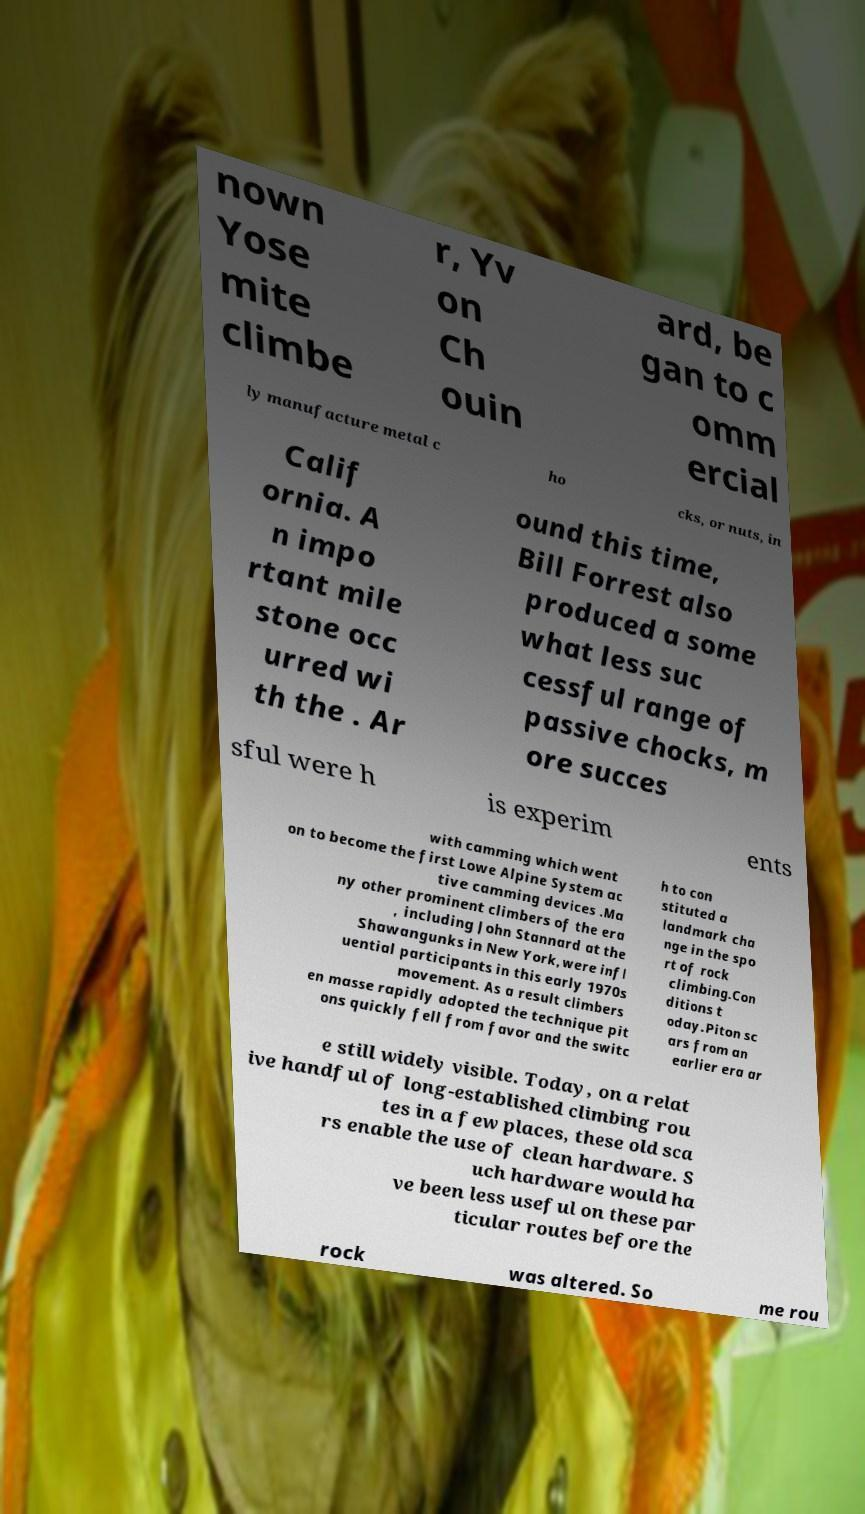There's text embedded in this image that I need extracted. Can you transcribe it verbatim? nown Yose mite climbe r, Yv on Ch ouin ard, be gan to c omm ercial ly manufacture metal c ho cks, or nuts, in Calif ornia. A n impo rtant mile stone occ urred wi th the . Ar ound this time, Bill Forrest also produced a some what less suc cessful range of passive chocks, m ore succes sful were h is experim ents with camming which went on to become the first Lowe Alpine System ac tive camming devices .Ma ny other prominent climbers of the era , including John Stannard at the Shawangunks in New York,were infl uential participants in this early 1970s movement. As a result climbers en masse rapidly adopted the technique pit ons quickly fell from favor and the switc h to con stituted a landmark cha nge in the spo rt of rock climbing.Con ditions t oday.Piton sc ars from an earlier era ar e still widely visible. Today, on a relat ive handful of long-established climbing rou tes in a few places, these old sca rs enable the use of clean hardware. S uch hardware would ha ve been less useful on these par ticular routes before the rock was altered. So me rou 